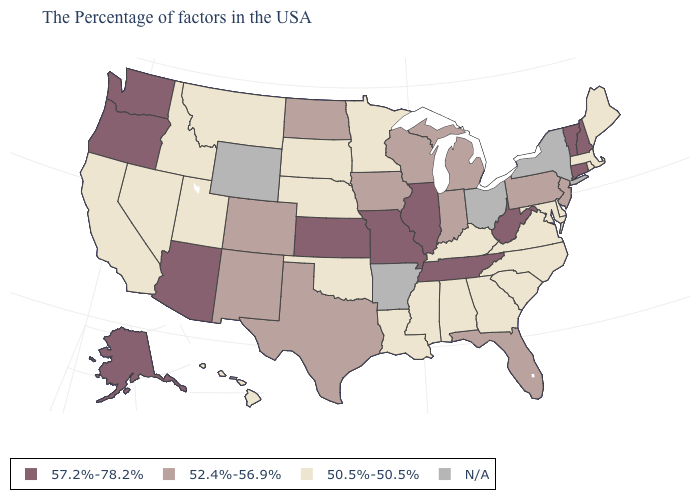What is the highest value in the West ?
Write a very short answer. 57.2%-78.2%. What is the value of Alabama?
Short answer required. 50.5%-50.5%. Which states hav the highest value in the South?
Quick response, please. West Virginia, Tennessee. Which states have the lowest value in the West?
Give a very brief answer. Utah, Montana, Idaho, Nevada, California, Hawaii. What is the lowest value in the USA?
Keep it brief. 50.5%-50.5%. Does Nebraska have the lowest value in the MidWest?
Keep it brief. Yes. Name the states that have a value in the range 50.5%-50.5%?
Quick response, please. Maine, Massachusetts, Rhode Island, Delaware, Maryland, Virginia, North Carolina, South Carolina, Georgia, Kentucky, Alabama, Mississippi, Louisiana, Minnesota, Nebraska, Oklahoma, South Dakota, Utah, Montana, Idaho, Nevada, California, Hawaii. What is the value of Florida?
Write a very short answer. 52.4%-56.9%. What is the lowest value in states that border Illinois?
Keep it brief. 50.5%-50.5%. What is the value of New Hampshire?
Write a very short answer. 57.2%-78.2%. What is the highest value in states that border Alabama?
Give a very brief answer. 57.2%-78.2%. What is the value of Iowa?
Write a very short answer. 52.4%-56.9%. Which states have the lowest value in the Northeast?
Short answer required. Maine, Massachusetts, Rhode Island. Does the map have missing data?
Quick response, please. Yes. 